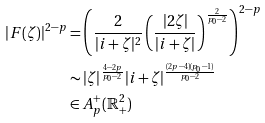Convert formula to latex. <formula><loc_0><loc_0><loc_500><loc_500>| F ( \zeta ) | ^ { 2 - p } & = \left ( \frac { 2 } { | i + \zeta | ^ { 2 } } \left ( \frac { | 2 \zeta | } { | i + \zeta | } \right ) ^ { \frac { 2 } { p _ { 0 } - 2 } } \right ) ^ { 2 - p } \\ & \sim | \zeta | ^ { \frac { 4 - 2 p } { p _ { 0 } - 2 } } | i + \zeta | ^ { \frac { ( 2 p - 4 ) ( p _ { 0 } - 1 ) } { p _ { 0 } - 2 } } \\ & \in A ^ { + } _ { p } ( \mathbb { R } ^ { 2 } _ { + } )</formula> 